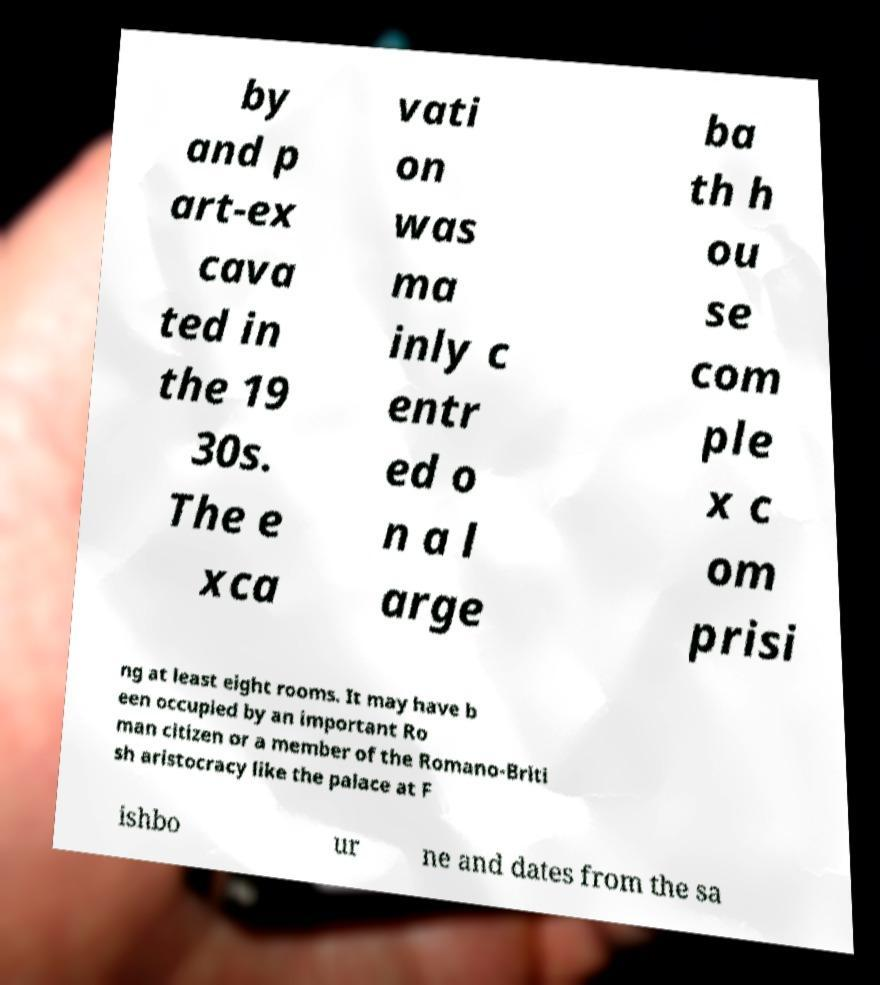What messages or text are displayed in this image? I need them in a readable, typed format. by and p art-ex cava ted in the 19 30s. The e xca vati on was ma inly c entr ed o n a l arge ba th h ou se com ple x c om prisi ng at least eight rooms. It may have b een occupied by an important Ro man citizen or a member of the Romano-Briti sh aristocracy like the palace at F ishbo ur ne and dates from the sa 